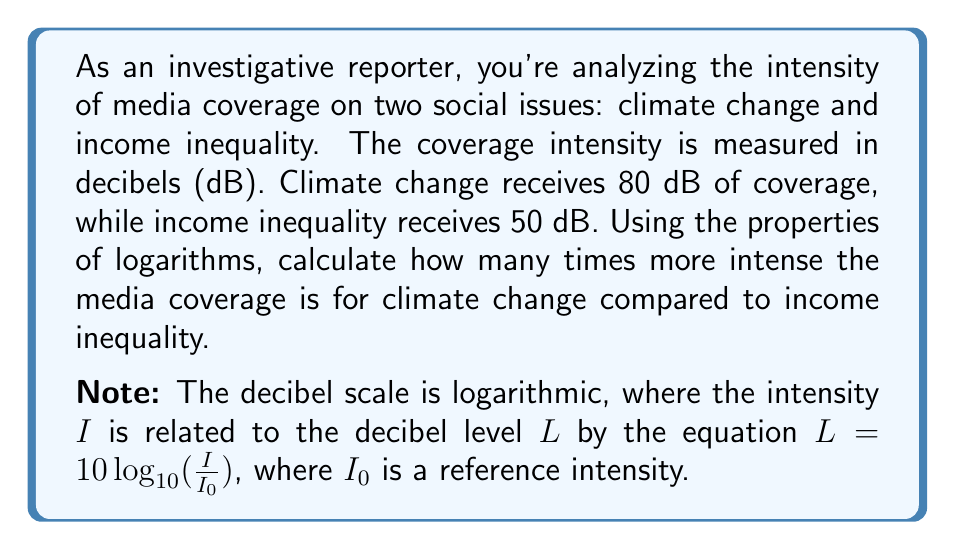What is the answer to this math problem? To solve this problem, we'll use the properties of logarithms and the given decibel equation. Let's approach this step-by-step:

1) The decibel equation is given as:
   $L = 10 \log_{10}(\frac{I}{I_0})$

2) Let $I_1$ be the intensity for climate change and $I_2$ be the intensity for income inequality. We can write two equations:

   $80 = 10 \log_{10}(\frac{I_1}{I_0})$
   $50 = 10 \log_{10}(\frac{I_2}{I_0})$

3) Divide the first equation by the second:

   $\frac{80}{50} = \frac{10 \log_{10}(\frac{I_1}{I_0})}{10 \log_{10}(\frac{I_2}{I_0})}$

4) Simplify:

   $\frac{8}{5} = \frac{\log_{10}(\frac{I_1}{I_0})}{\log_{10}(\frac{I_2}{I_0})}$

5) Using the logarithm property $\log_a(x) - \log_a(y) = \log_a(\frac{x}{y})$, we can rewrite this as:

   $\frac{8}{5} = \log_{10}(\frac{I_1}{I_2})$

6) Now, we can solve for $\frac{I_1}{I_2}$:

   $10^{\frac{8}{5}} = \frac{I_1}{I_2}$

7) Calculate the result:

   $10^{\frac{8}{5}} = 10^{1.6} \approx 39.81$

Therefore, the intensity of media coverage for climate change is approximately 39.81 times greater than the coverage for income inequality.
Answer: The media coverage for climate change is approximately 39.81 times more intense than the coverage for income inequality. 